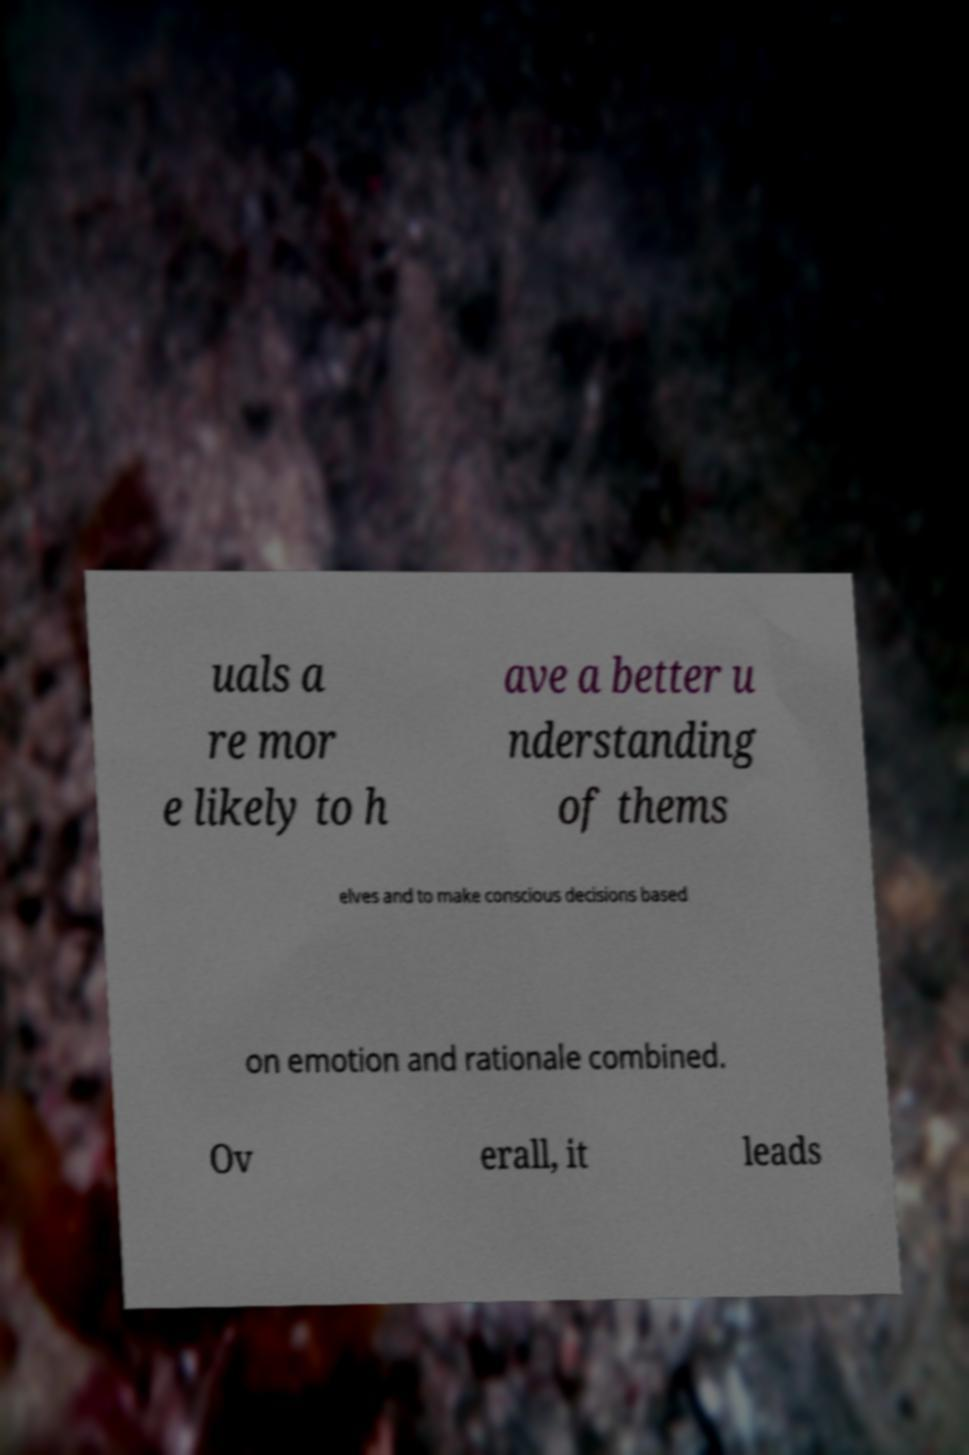I need the written content from this picture converted into text. Can you do that? uals a re mor e likely to h ave a better u nderstanding of thems elves and to make conscious decisions based on emotion and rationale combined. Ov erall, it leads 